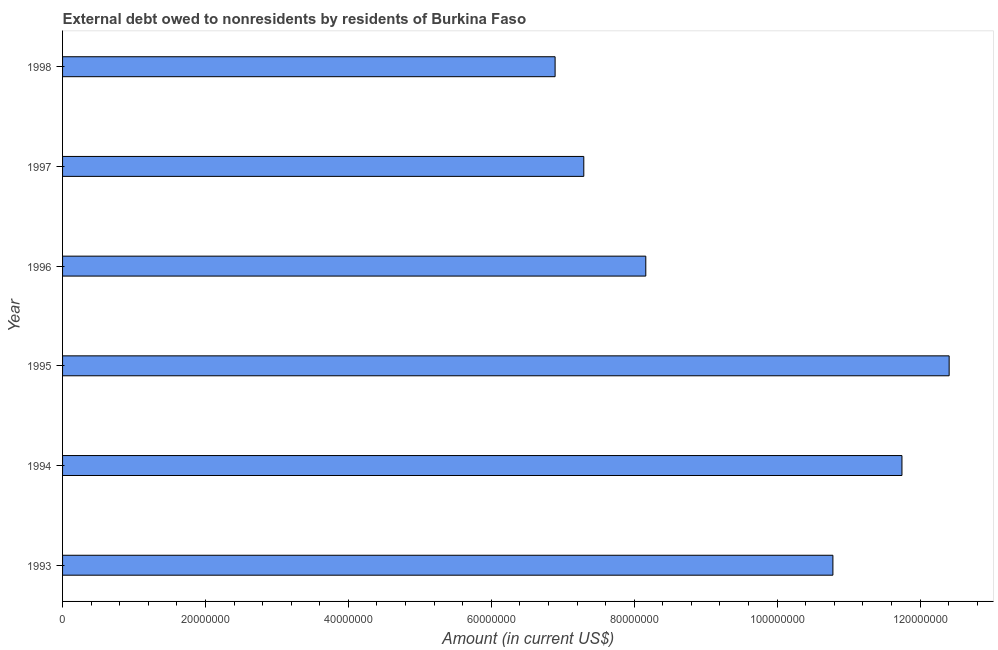Does the graph contain any zero values?
Offer a very short reply. No. Does the graph contain grids?
Provide a succinct answer. No. What is the title of the graph?
Your response must be concise. External debt owed to nonresidents by residents of Burkina Faso. What is the debt in 1996?
Ensure brevity in your answer.  8.16e+07. Across all years, what is the maximum debt?
Offer a very short reply. 1.24e+08. Across all years, what is the minimum debt?
Provide a succinct answer. 6.89e+07. In which year was the debt minimum?
Your answer should be compact. 1998. What is the sum of the debt?
Provide a short and direct response. 5.73e+08. What is the difference between the debt in 1995 and 1997?
Ensure brevity in your answer.  5.11e+07. What is the average debt per year?
Keep it short and to the point. 9.55e+07. What is the median debt?
Offer a terse response. 9.47e+07. In how many years, is the debt greater than 12000000 US$?
Offer a terse response. 6. What is the ratio of the debt in 1994 to that in 1997?
Your response must be concise. 1.61. What is the difference between the highest and the second highest debt?
Provide a succinct answer. 6.61e+06. What is the difference between the highest and the lowest debt?
Ensure brevity in your answer.  5.51e+07. How many years are there in the graph?
Your response must be concise. 6. What is the difference between two consecutive major ticks on the X-axis?
Give a very brief answer. 2.00e+07. Are the values on the major ticks of X-axis written in scientific E-notation?
Provide a short and direct response. No. What is the Amount (in current US$) of 1993?
Provide a short and direct response. 1.08e+08. What is the Amount (in current US$) of 1994?
Your response must be concise. 1.17e+08. What is the Amount (in current US$) of 1995?
Ensure brevity in your answer.  1.24e+08. What is the Amount (in current US$) of 1996?
Give a very brief answer. 8.16e+07. What is the Amount (in current US$) of 1997?
Offer a very short reply. 7.29e+07. What is the Amount (in current US$) in 1998?
Provide a succinct answer. 6.89e+07. What is the difference between the Amount (in current US$) in 1993 and 1994?
Keep it short and to the point. -9.66e+06. What is the difference between the Amount (in current US$) in 1993 and 1995?
Your answer should be compact. -1.63e+07. What is the difference between the Amount (in current US$) in 1993 and 1996?
Offer a terse response. 2.62e+07. What is the difference between the Amount (in current US$) in 1993 and 1997?
Provide a short and direct response. 3.49e+07. What is the difference between the Amount (in current US$) in 1993 and 1998?
Your answer should be compact. 3.89e+07. What is the difference between the Amount (in current US$) in 1994 and 1995?
Your answer should be compact. -6.61e+06. What is the difference between the Amount (in current US$) in 1994 and 1996?
Your answer should be compact. 3.58e+07. What is the difference between the Amount (in current US$) in 1994 and 1997?
Your answer should be very brief. 4.45e+07. What is the difference between the Amount (in current US$) in 1994 and 1998?
Make the answer very short. 4.85e+07. What is the difference between the Amount (in current US$) in 1995 and 1996?
Make the answer very short. 4.25e+07. What is the difference between the Amount (in current US$) in 1995 and 1997?
Keep it short and to the point. 5.11e+07. What is the difference between the Amount (in current US$) in 1995 and 1998?
Make the answer very short. 5.51e+07. What is the difference between the Amount (in current US$) in 1996 and 1997?
Keep it short and to the point. 8.68e+06. What is the difference between the Amount (in current US$) in 1996 and 1998?
Your answer should be compact. 1.27e+07. What is the difference between the Amount (in current US$) in 1997 and 1998?
Offer a terse response. 4.02e+06. What is the ratio of the Amount (in current US$) in 1993 to that in 1994?
Your response must be concise. 0.92. What is the ratio of the Amount (in current US$) in 1993 to that in 1995?
Ensure brevity in your answer.  0.87. What is the ratio of the Amount (in current US$) in 1993 to that in 1996?
Your answer should be compact. 1.32. What is the ratio of the Amount (in current US$) in 1993 to that in 1997?
Offer a very short reply. 1.48. What is the ratio of the Amount (in current US$) in 1993 to that in 1998?
Offer a terse response. 1.56. What is the ratio of the Amount (in current US$) in 1994 to that in 1995?
Your response must be concise. 0.95. What is the ratio of the Amount (in current US$) in 1994 to that in 1996?
Offer a terse response. 1.44. What is the ratio of the Amount (in current US$) in 1994 to that in 1997?
Give a very brief answer. 1.61. What is the ratio of the Amount (in current US$) in 1994 to that in 1998?
Provide a succinct answer. 1.7. What is the ratio of the Amount (in current US$) in 1995 to that in 1996?
Make the answer very short. 1.52. What is the ratio of the Amount (in current US$) in 1995 to that in 1997?
Offer a very short reply. 1.7. What is the ratio of the Amount (in current US$) in 1996 to that in 1997?
Your answer should be very brief. 1.12. What is the ratio of the Amount (in current US$) in 1996 to that in 1998?
Keep it short and to the point. 1.18. What is the ratio of the Amount (in current US$) in 1997 to that in 1998?
Your response must be concise. 1.06. 